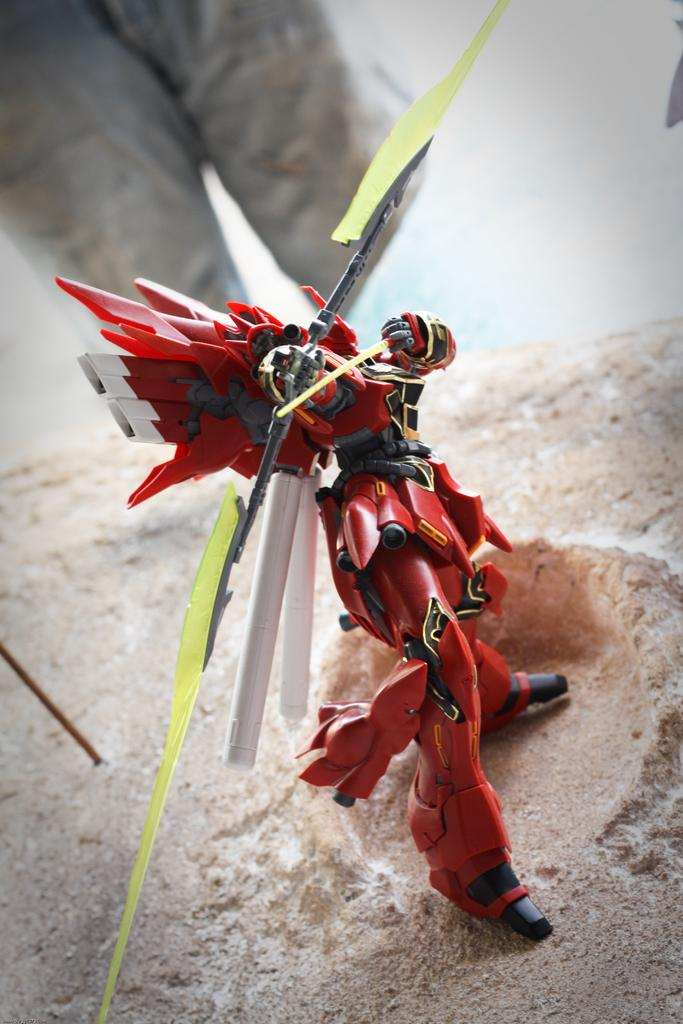What object is on the ground in the image? There is a toy on the ground in the image. Can you describe the position of the person in relation to the toy? The legs of a person are visible behind the toy. What type of icicle can be seen hanging from the toy in the image? There is no icicle present in the image; it is a toy on the ground with a person's legs visible behind it. 